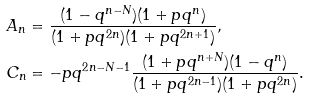Convert formula to latex. <formula><loc_0><loc_0><loc_500><loc_500>A _ { n } & = \frac { ( 1 - q ^ { n - N } ) ( 1 + p q ^ { n } ) } { ( 1 + p q ^ { 2 n } ) ( 1 + p q ^ { 2 n + 1 } ) } , \\ C _ { n } & = - p q ^ { 2 n - N - 1 } \frac { ( 1 + p q ^ { n + N } ) ( 1 - q ^ { n } ) } { ( 1 + p q ^ { 2 n - 1 } ) ( 1 + p q ^ { 2 n } ) } .</formula> 